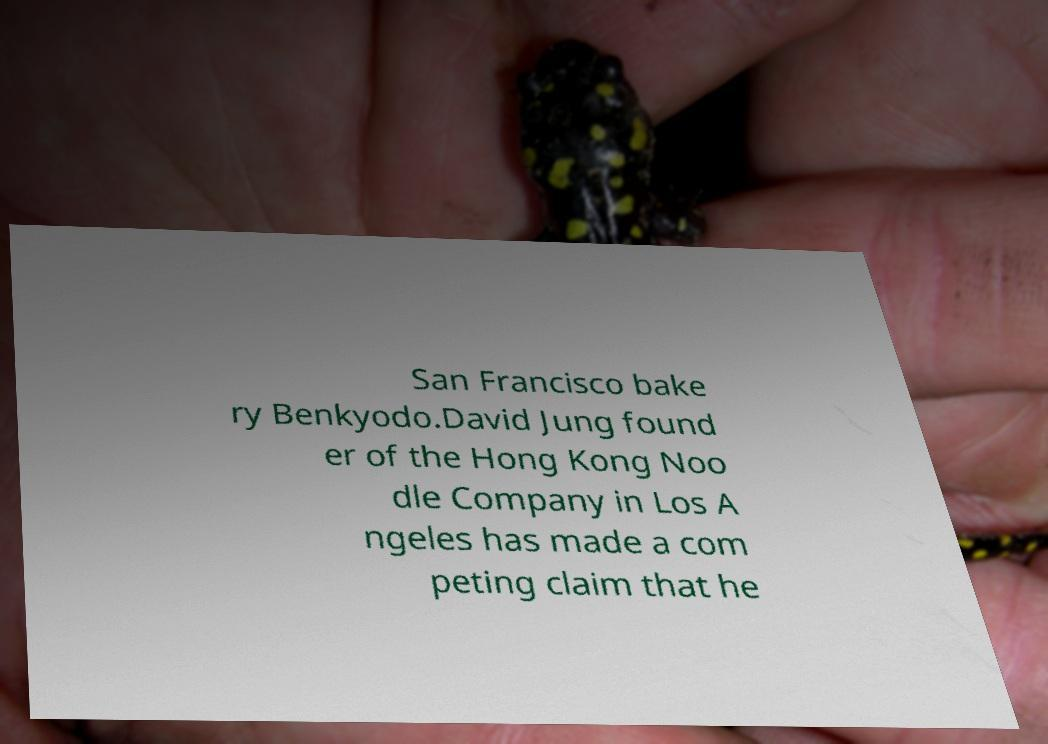Can you read and provide the text displayed in the image?This photo seems to have some interesting text. Can you extract and type it out for me? San Francisco bake ry Benkyodo.David Jung found er of the Hong Kong Noo dle Company in Los A ngeles has made a com peting claim that he 